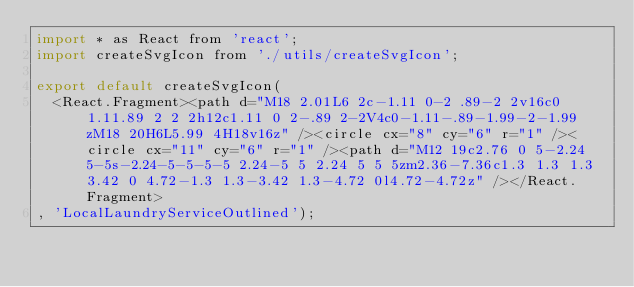Convert code to text. <code><loc_0><loc_0><loc_500><loc_500><_JavaScript_>import * as React from 'react';
import createSvgIcon from './utils/createSvgIcon';

export default createSvgIcon(
  <React.Fragment><path d="M18 2.01L6 2c-1.11 0-2 .89-2 2v16c0 1.11.89 2 2 2h12c1.11 0 2-.89 2-2V4c0-1.11-.89-1.99-2-1.99zM18 20H6L5.99 4H18v16z" /><circle cx="8" cy="6" r="1" /><circle cx="11" cy="6" r="1" /><path d="M12 19c2.76 0 5-2.24 5-5s-2.24-5-5-5-5 2.24-5 5 2.24 5 5 5zm2.36-7.36c1.3 1.3 1.3 3.42 0 4.72-1.3 1.3-3.42 1.3-4.72 0l4.72-4.72z" /></React.Fragment>
, 'LocalLaundryServiceOutlined');
</code> 